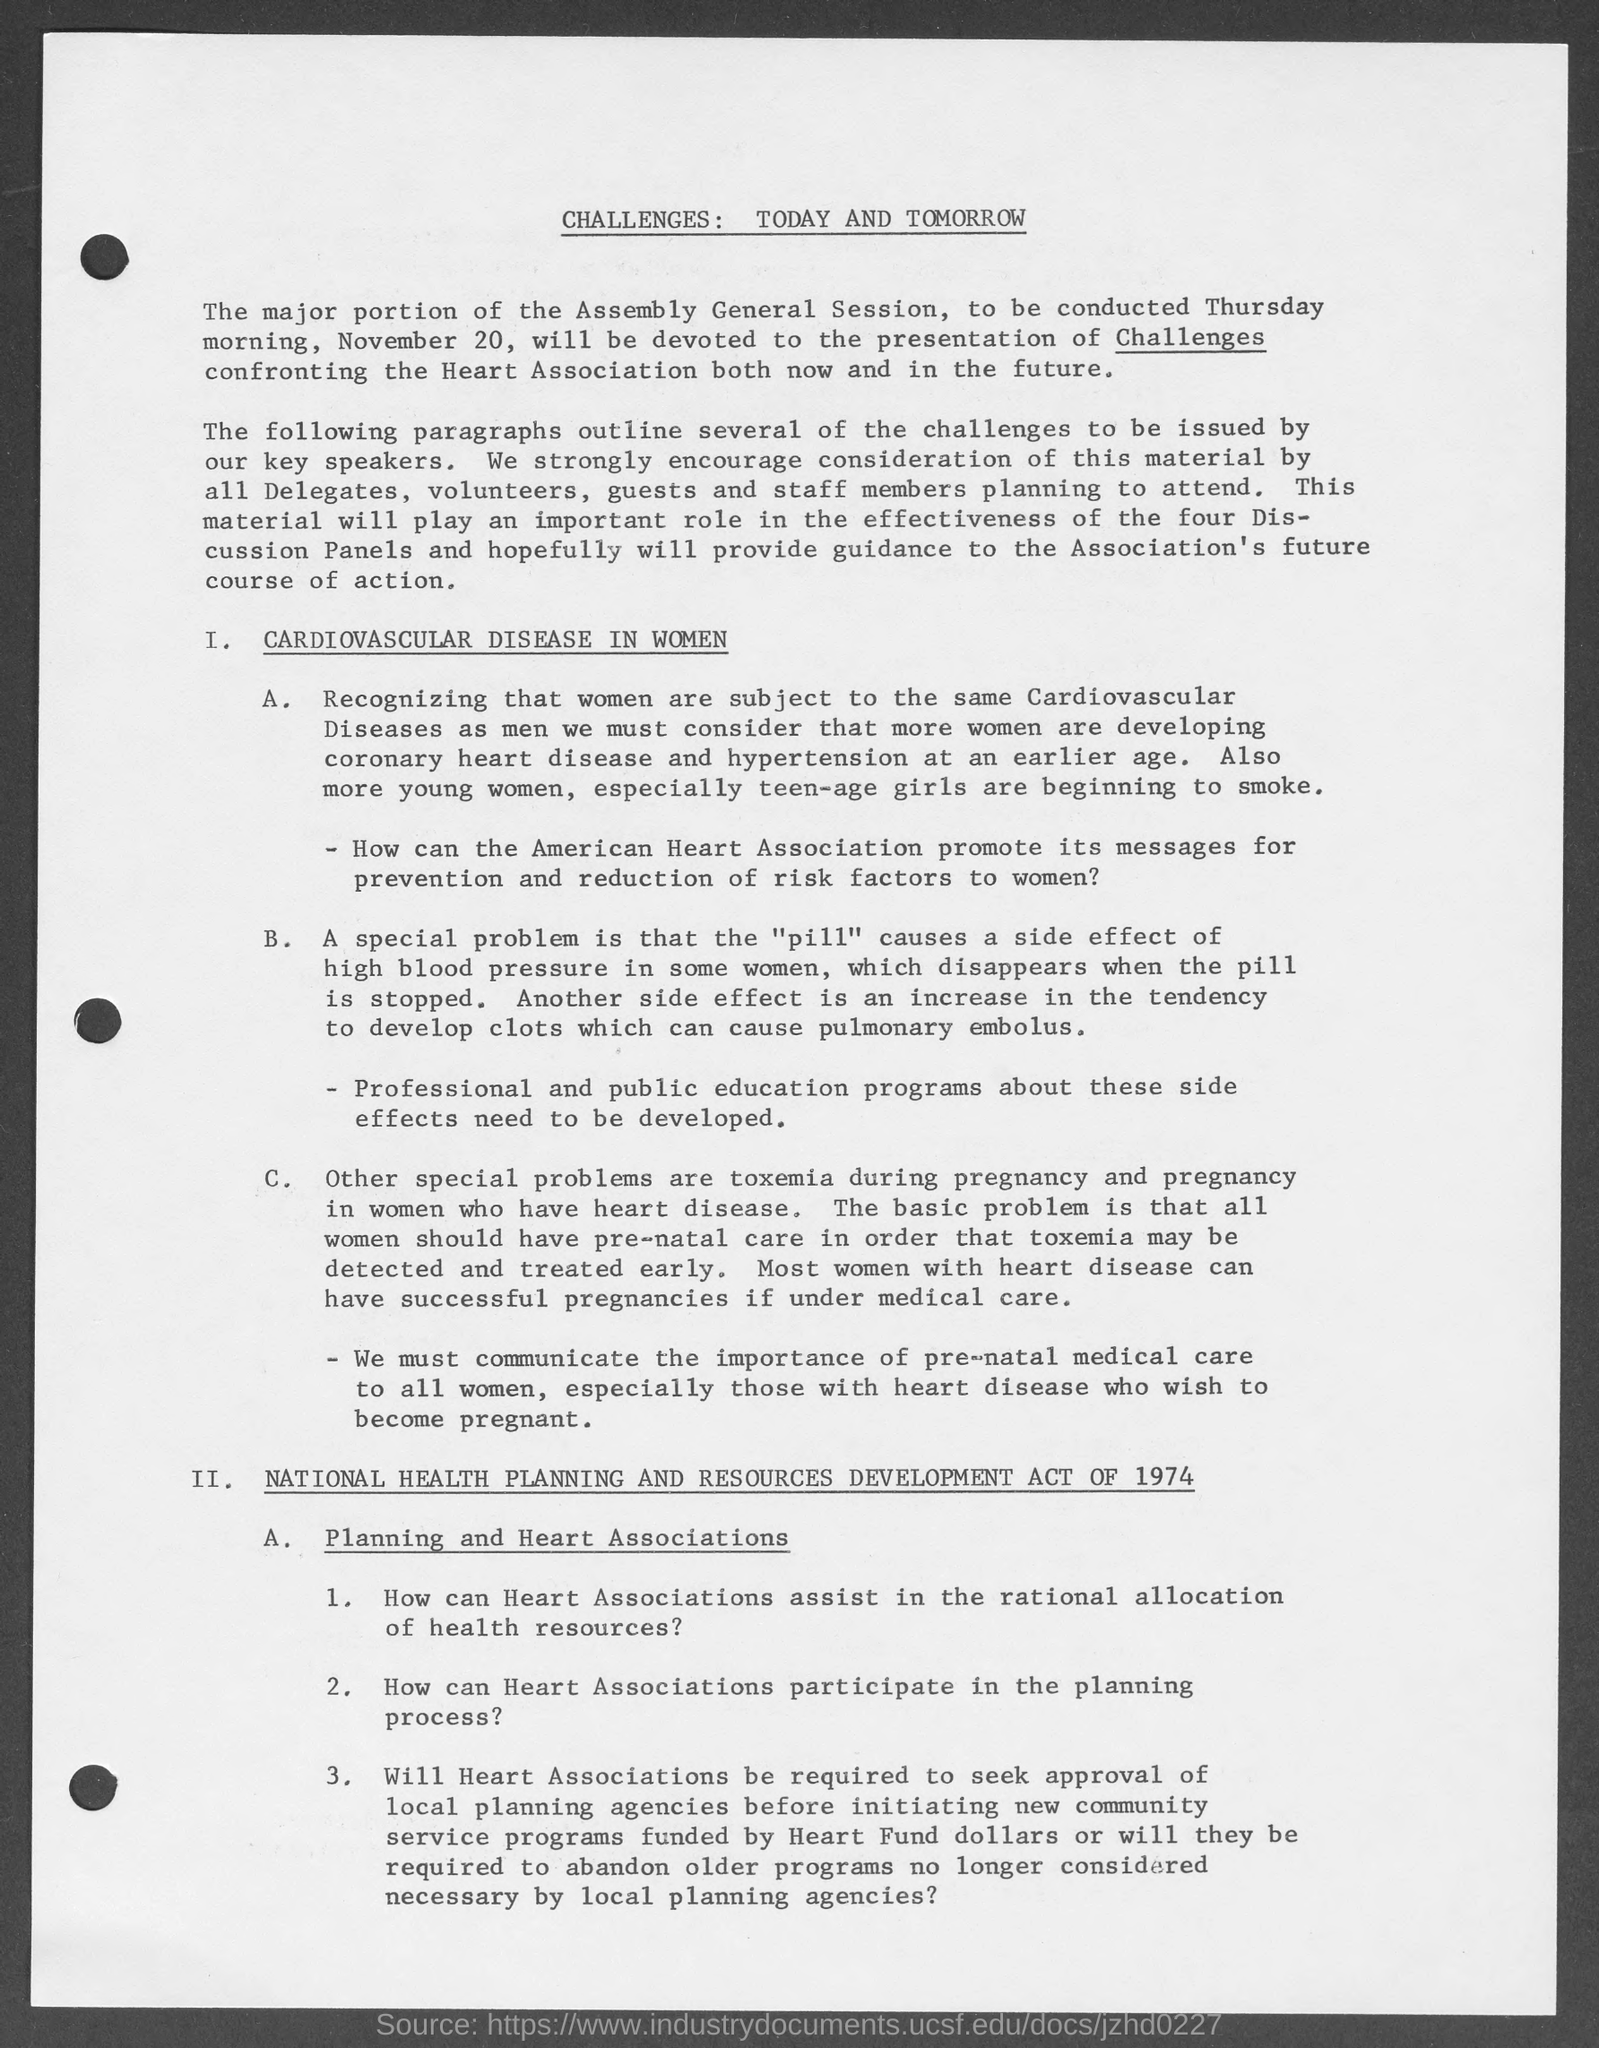Can you tell me more about the role of Heart Associations as mentioned in the document? According to the document, Heart Associations are given tasks associated with national health planning. They are expected to assist in the rational allocation of health resources, participate in the planning process, and seek approval from local planning agencies before initiating new community service programs. The discussion revolves around effective use of resources and the potential need to evolve past programs to meet current health planning requirements. 